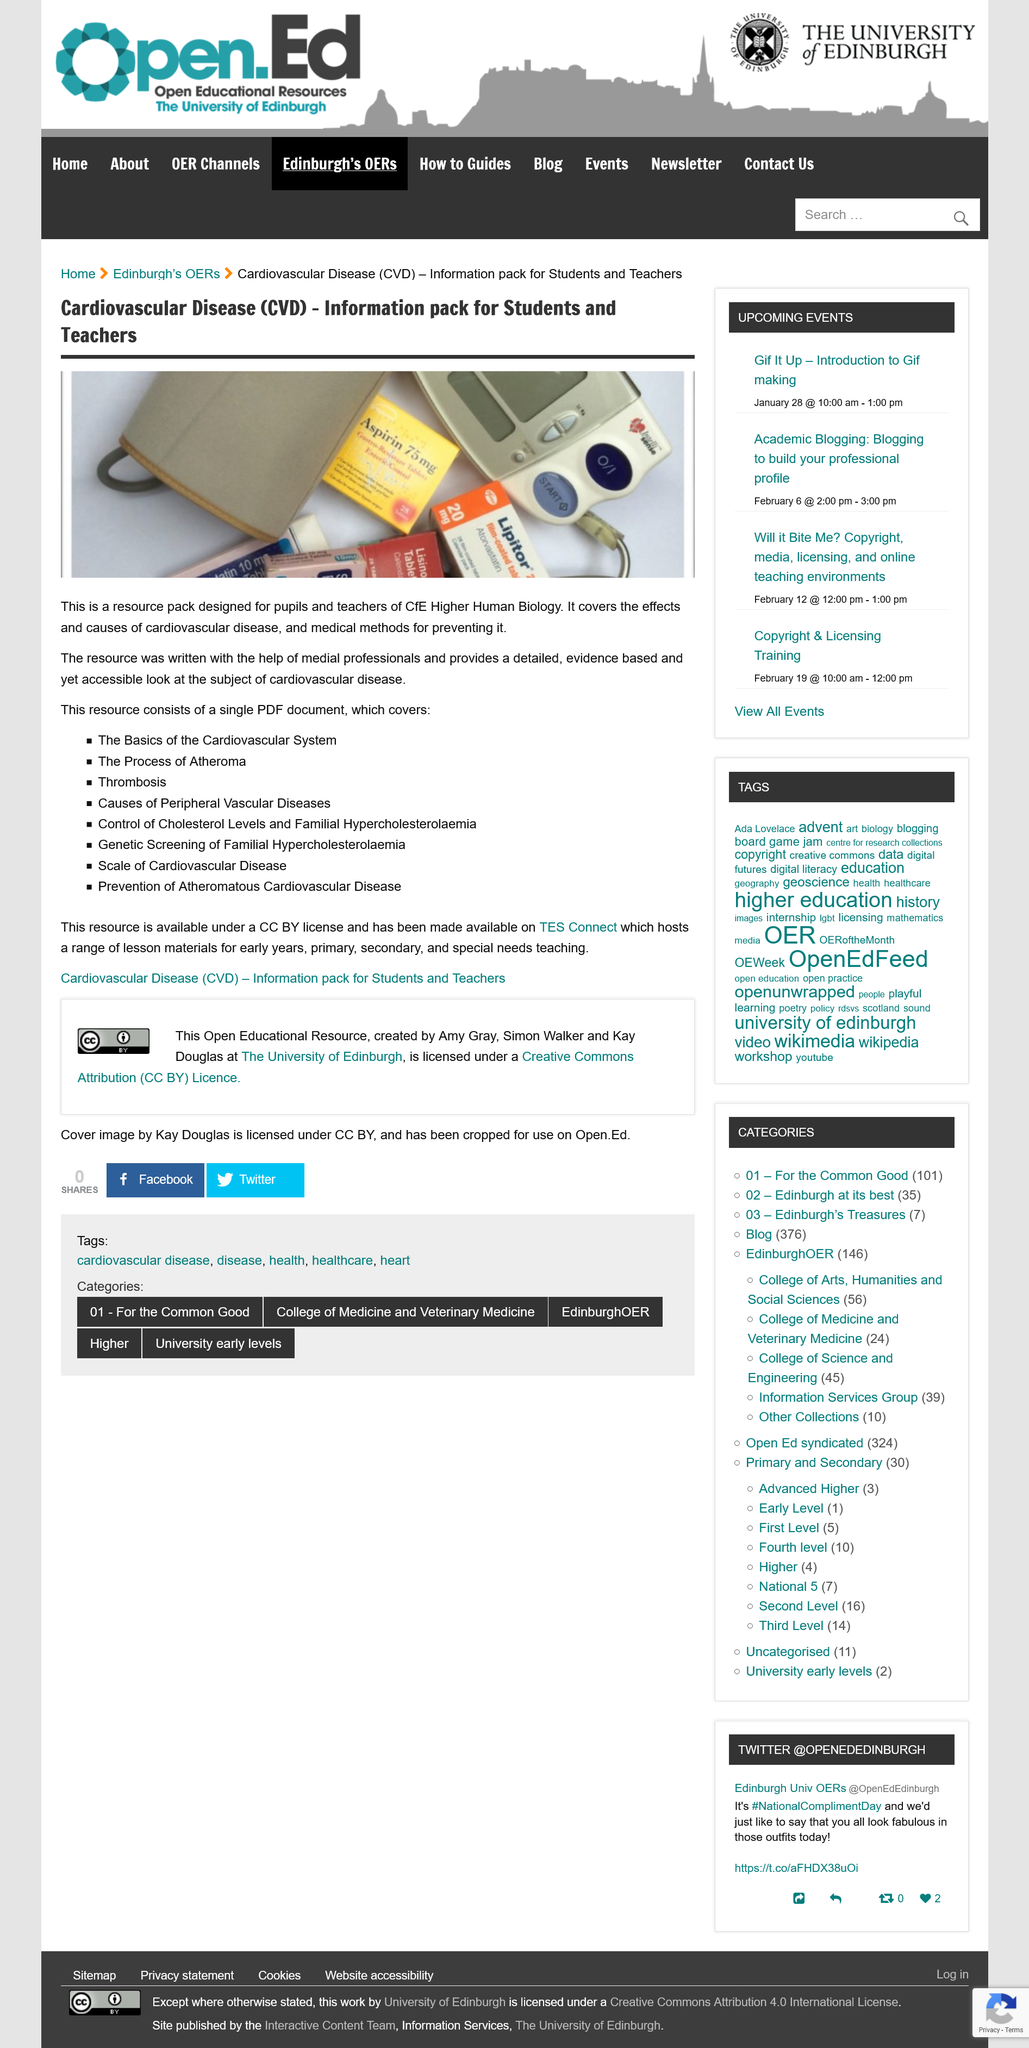Give some essential details in this illustration. The information pack is intended for students and teachers. The provided resource pack is in PDF format. The information pack is focused on Cardiovascular Disease. 